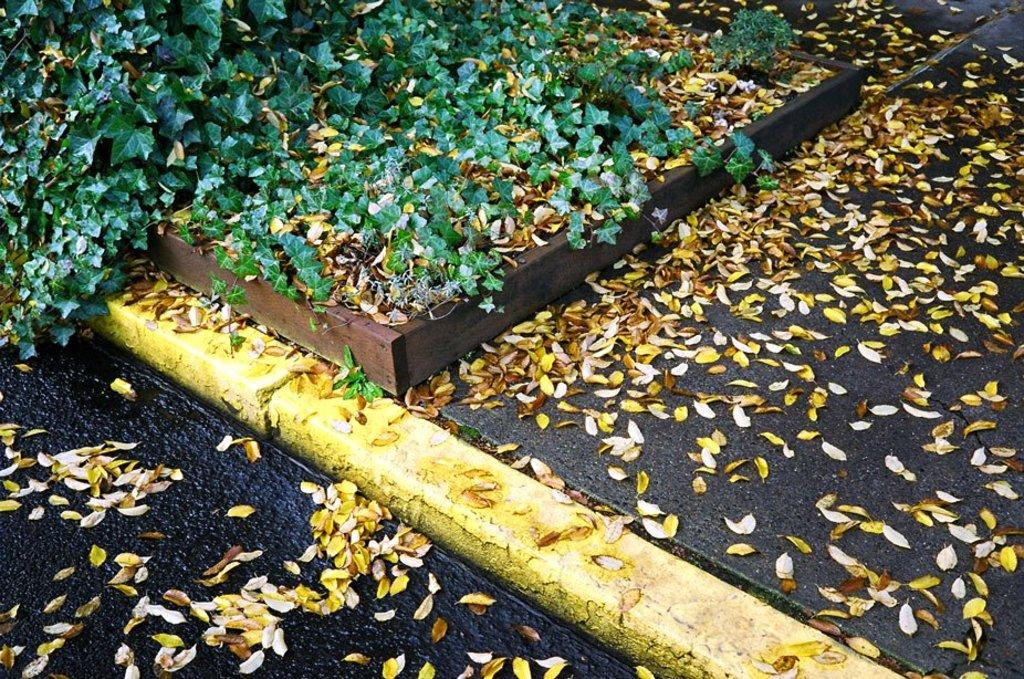What type of vegetation is present at the bottom of the image? There are leaves at the bottom of the image. What type of vegetation is present at the top of the image? There are plants at the top of the image. How many deer can be seen in the image? There are no deer present in the image. What level of difficulty is the guide in the image rated? There is no guide present in the image, so it cannot be rated for difficulty. 